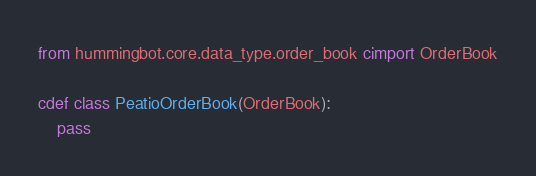Convert code to text. <code><loc_0><loc_0><loc_500><loc_500><_Cython_>from hummingbot.core.data_type.order_book cimport OrderBook

cdef class PeatioOrderBook(OrderBook):
    pass
</code> 